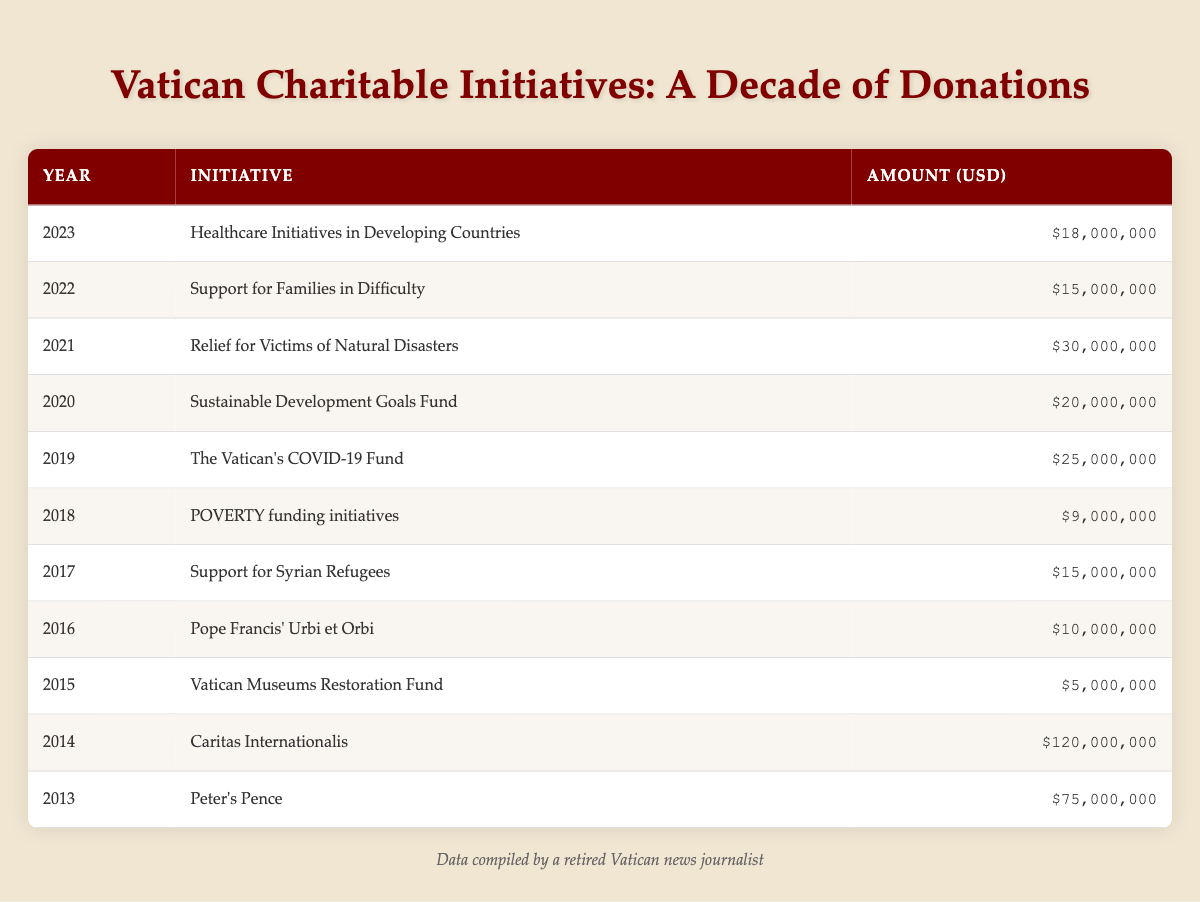What was the highest amount donated in a single year? From the table, we see that Caritas Internationalis received the highest donation in 2014 with an amount of 120,000,000 USD.
Answer: 120,000,000 USD What were the donations for healthcare initiatives in 2023? The row for the year 2023 shows the initiative "Healthcare Initiatives in Developing Countries" with a donation amount of 18,000,000 USD.
Answer: 18,000,000 USD How many initiatives received more than 20 million USD? To find this, we can count the rows with amounts greater than 20 million USD for the relevant initiatives: Caritas Internationalis (120,000,000), Peter's Pence (75,000,000), Relief for Victims of Natural Disasters (30,000,000), and The Vatican's COVID-19 Fund (25,000,000). This totals four initiatives.
Answer: 4 What is the total amount donated from 2015 to 2020? We sum the amounts from the years 2015 to 2020, which are 5,000,000 (2015) + 10,000,000 (2016) + 15,000,000 (2017) + 9,000,000 (2018) + 25,000,000 (2019) + 20,000,000 (2020) = 79,000,000.
Answer: 79,000,000 Was the amount donated to the Vatican Museums Restoration Fund greater than the amount donated to healthcare initiatives in 2023? Looking at the respective years, the Vatican Museums Restoration Fund received 5,000,000 USD in 2015, while healthcare initiatives in 2023 amounted to 18,000,000 USD. The amount in 2023 is indeed greater than in 2015, so the statement is true.
Answer: Yes Which year experienced a decrease in donations compared to the previous year? Observing the table, we note that from 2019 to 2020 the donations decreased from 25,000,000 USD to 20,000,000 USD, indicating a decrease in donations.
Answer: 2020 What was the average donation amount across the entire decade? To find the average, we calculate the total amount donated over the years from 2013 to 2023, which is 75000000 + 120000000 + 5000000 + 10000000 + 15000000 + 9000000 + 25000000 + 20000000 + 30000000 + 15000000 + 18000000 = 208000000. There are 11 years, thus the average would be 208000000/11 = 18909090.91, so rounded to two decimal places, it is 18909091.
Answer: 18909091 Which initiative received the least amount in donations over the decade? By reviewing the table, we check the amounts for each initiative and find that the Vatican Museums Restoration Fund had the lowest donation of 5,000,000 USD in 2015.
Answer: Vatican Museums Restoration Fund 